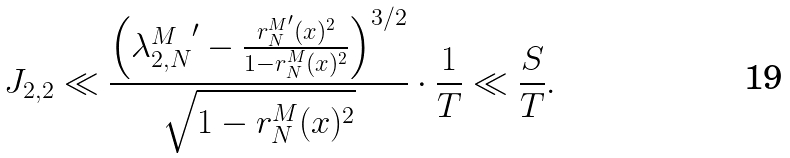<formula> <loc_0><loc_0><loc_500><loc_500>J _ { 2 , 2 } \ll \frac { \left ( { \lambda _ { 2 , N } ^ { M } } ^ { \prime } - \frac { { r _ { N } ^ { M } } ^ { \prime } ( x ) ^ { 2 } } { 1 - r _ { N } ^ { M } ( x ) ^ { 2 } } \right ) ^ { 3 / 2 } } { \sqrt { 1 - { r _ { N } ^ { M } } ( x ) ^ { 2 } } } \cdot \frac { 1 } { T } \ll \frac { S } { T } .</formula> 